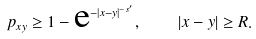Convert formula to latex. <formula><loc_0><loc_0><loc_500><loc_500>p _ { x y } \geq 1 - \text  e^{-|x-y|^{-s^{\prime}}} , \quad | x - y | \geq R .</formula> 